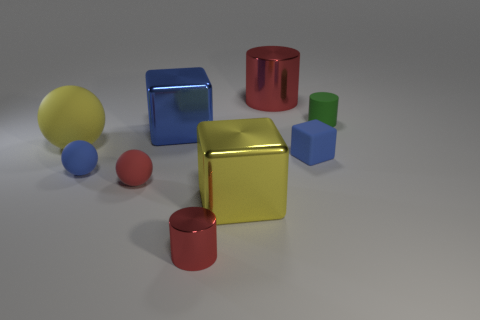Is the big matte object the same color as the big cylinder?
Give a very brief answer. No. Is the number of green matte cylinders that are left of the small cube less than the number of large yellow rubber things that are on the right side of the small blue sphere?
Keep it short and to the point. No. Is the number of metal cubes that are on the right side of the green rubber cylinder less than the number of tiny red shiny things?
Give a very brief answer. Yes. What is the material of the cylinder in front of the green matte cylinder?
Keep it short and to the point. Metal. How many other things are the same size as the yellow rubber ball?
Your response must be concise. 3. Is the number of matte cylinders less than the number of red metal things?
Make the answer very short. Yes. What shape is the tiny green thing?
Give a very brief answer. Cylinder. There is a shiny cylinder that is behind the red sphere; is it the same color as the tiny rubber cylinder?
Give a very brief answer. No. There is a big metal thing that is both behind the blue matte cube and in front of the large metal cylinder; what shape is it?
Your answer should be very brief. Cube. There is a big object that is behind the large blue thing; what is its color?
Provide a succinct answer. Red. 